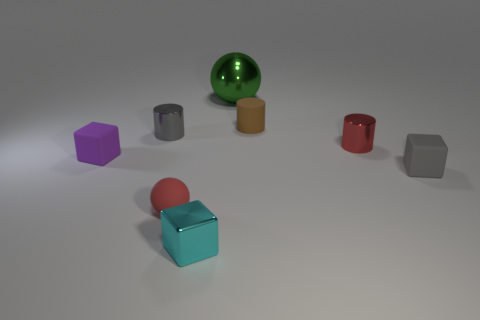There is a tiny cylinder that is the same color as the tiny sphere; what is it made of?
Offer a terse response. Metal. There is a cyan block that is the same size as the red rubber object; what is its material?
Your response must be concise. Metal. Are there any gray cylinders that have the same size as the red metal object?
Your response must be concise. Yes. There is a cylinder that is in front of the gray cylinder; does it have the same size as the purple rubber block?
Give a very brief answer. Yes. There is a small thing that is behind the purple matte cube and left of the tiny cyan metallic block; what is its shape?
Ensure brevity in your answer.  Cylinder. Is the number of tiny cylinders on the right side of the small cyan metal object greater than the number of big green metal objects?
Keep it short and to the point. Yes. There is a cube that is the same material as the large ball; what is its size?
Ensure brevity in your answer.  Small. What number of small balls are the same color as the large object?
Provide a succinct answer. 0. There is a ball on the left side of the large green sphere; is its color the same as the large ball?
Provide a short and direct response. No. Is the number of tiny matte blocks behind the small brown cylinder the same as the number of small gray matte objects that are behind the green ball?
Your answer should be very brief. Yes. 